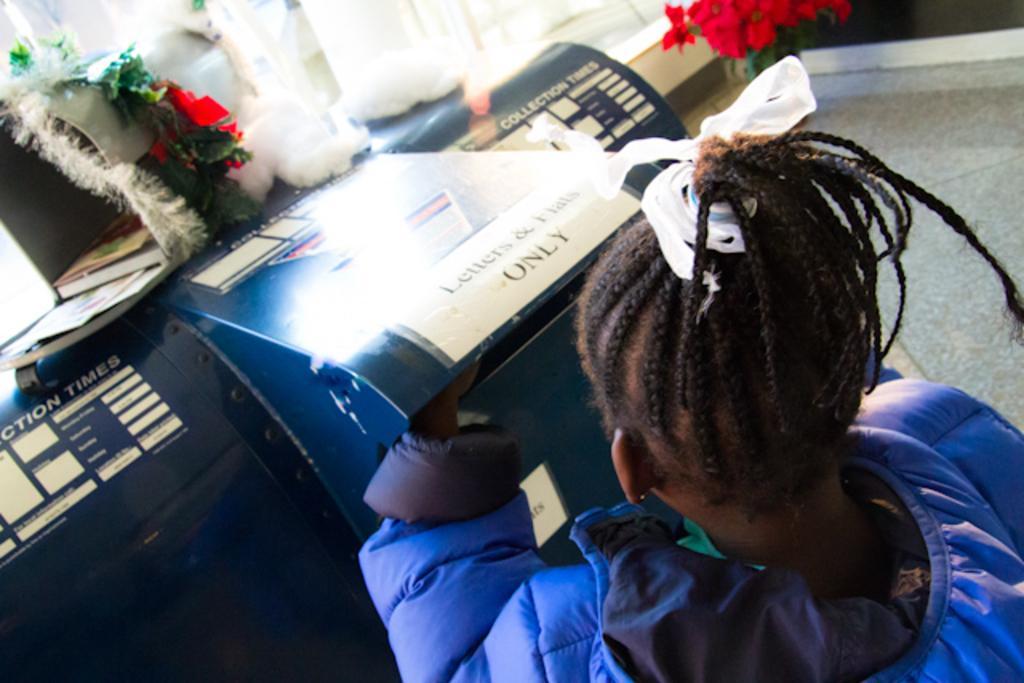Please provide a concise description of this image. In this image there is a person who is wearing the blue jacket is standing near the post box. On top of it there is a small house in which there are books. On the house there are decorative items. On the right side top there are flowers. In the background there is a white curtain. 